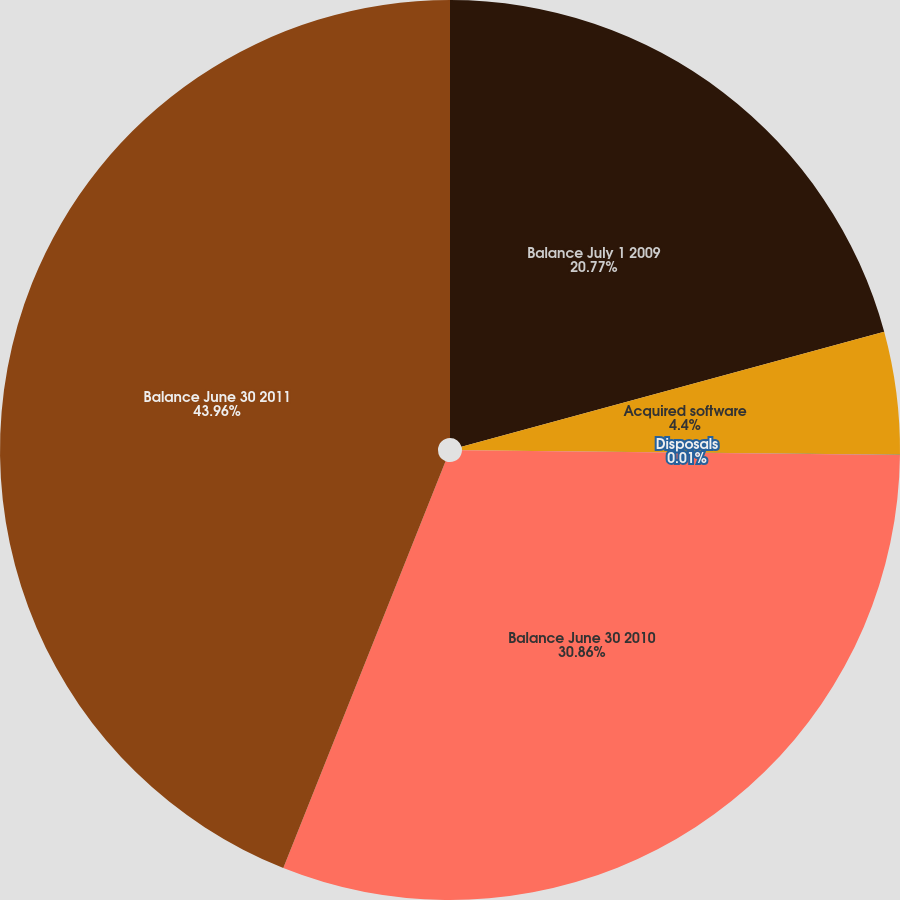<chart> <loc_0><loc_0><loc_500><loc_500><pie_chart><fcel>Balance July 1 2009<fcel>Acquired software<fcel>Disposals<fcel>Balance June 30 2010<fcel>Balance June 30 2011<nl><fcel>20.77%<fcel>4.4%<fcel>0.01%<fcel>30.86%<fcel>43.96%<nl></chart> 